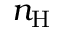Convert formula to latex. <formula><loc_0><loc_0><loc_500><loc_500>n _ { H }</formula> 